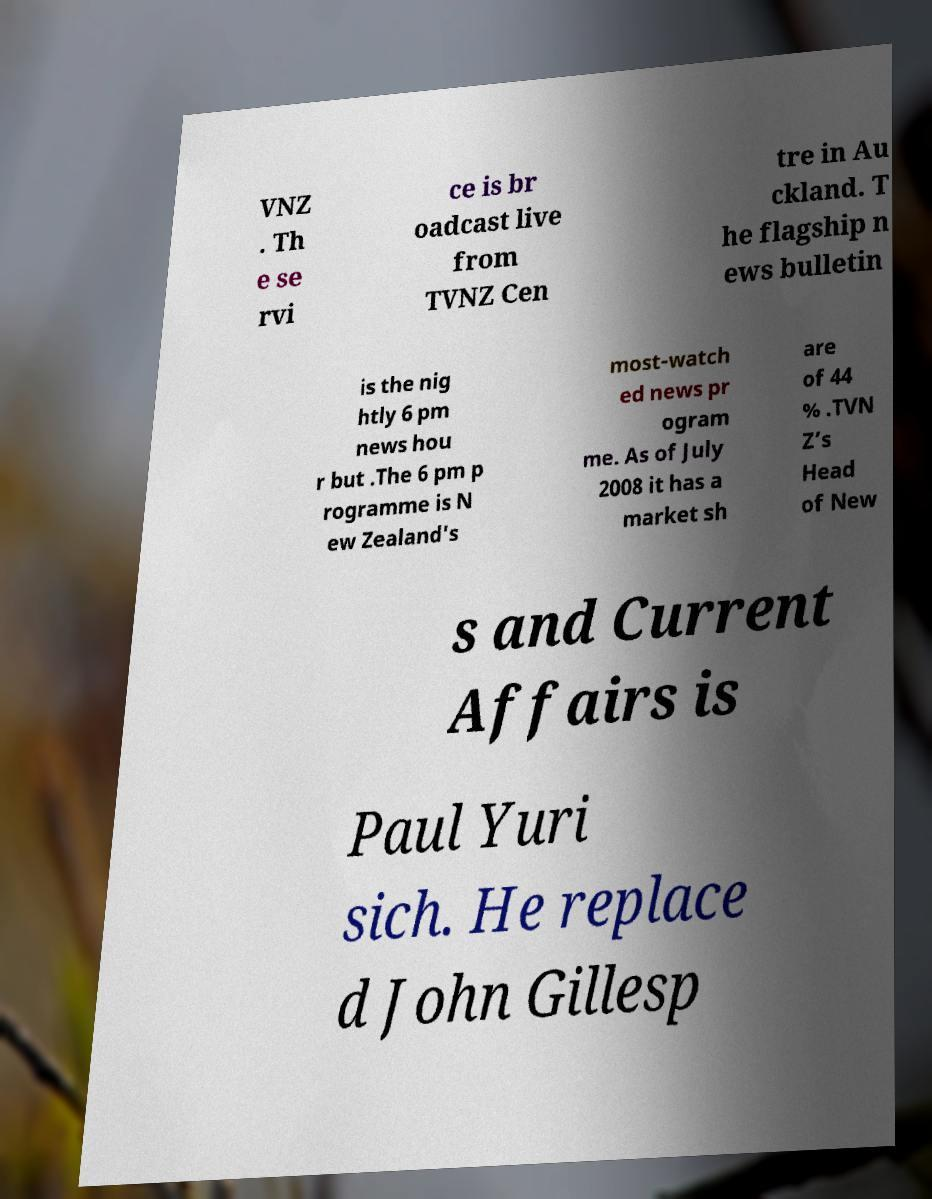Could you assist in decoding the text presented in this image and type it out clearly? VNZ . Th e se rvi ce is br oadcast live from TVNZ Cen tre in Au ckland. T he flagship n ews bulletin is the nig htly 6 pm news hou r but .The 6 pm p rogramme is N ew Zealand's most-watch ed news pr ogram me. As of July 2008 it has a market sh are of 44 % .TVN Z’s Head of New s and Current Affairs is Paul Yuri sich. He replace d John Gillesp 